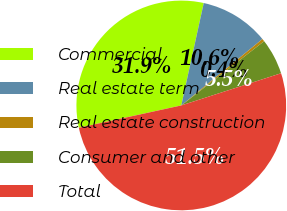Convert chart. <chart><loc_0><loc_0><loc_500><loc_500><pie_chart><fcel>Commercial<fcel>Real estate term<fcel>Real estate construction<fcel>Consumer and other<fcel>Total<nl><fcel>31.85%<fcel>10.65%<fcel>0.42%<fcel>5.53%<fcel>51.55%<nl></chart> 